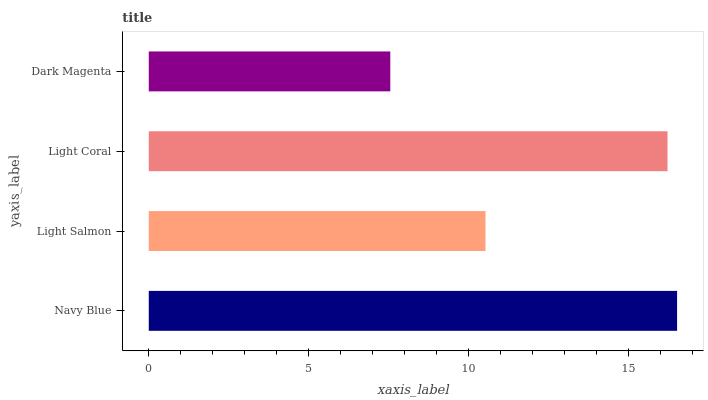Is Dark Magenta the minimum?
Answer yes or no. Yes. Is Navy Blue the maximum?
Answer yes or no. Yes. Is Light Salmon the minimum?
Answer yes or no. No. Is Light Salmon the maximum?
Answer yes or no. No. Is Navy Blue greater than Light Salmon?
Answer yes or no. Yes. Is Light Salmon less than Navy Blue?
Answer yes or no. Yes. Is Light Salmon greater than Navy Blue?
Answer yes or no. No. Is Navy Blue less than Light Salmon?
Answer yes or no. No. Is Light Coral the high median?
Answer yes or no. Yes. Is Light Salmon the low median?
Answer yes or no. Yes. Is Dark Magenta the high median?
Answer yes or no. No. Is Dark Magenta the low median?
Answer yes or no. No. 